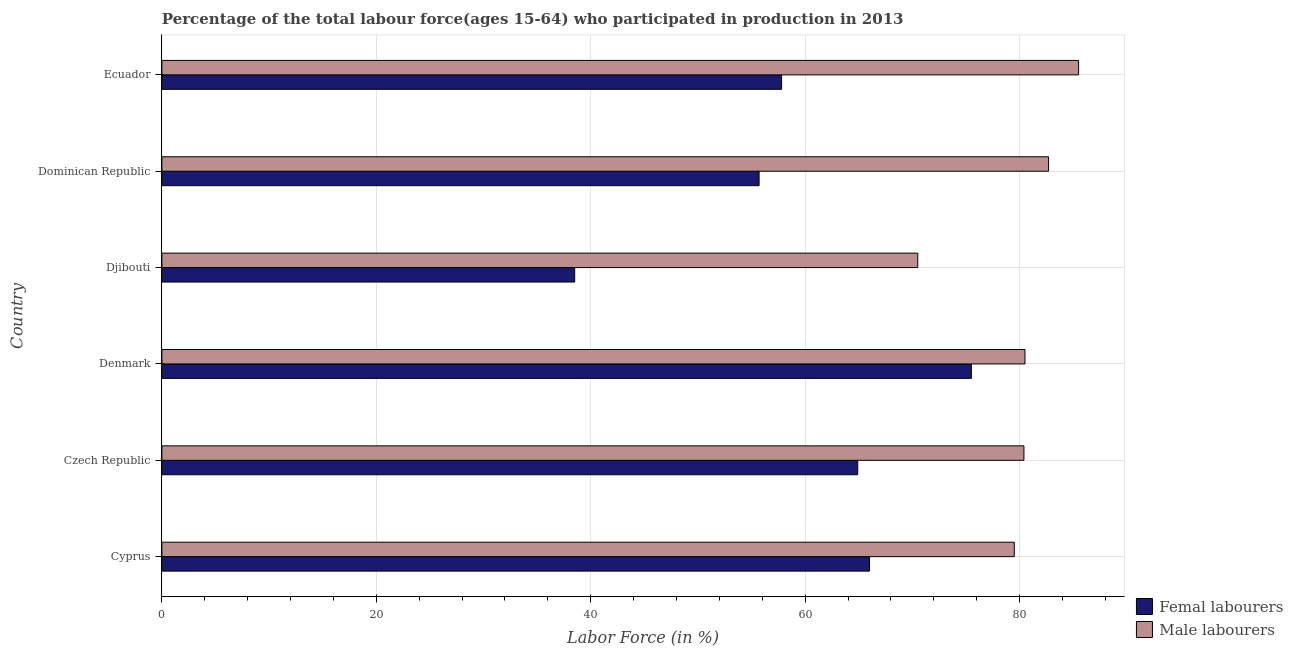Are the number of bars per tick equal to the number of legend labels?
Offer a terse response. Yes. How many bars are there on the 1st tick from the top?
Ensure brevity in your answer.  2. What is the label of the 5th group of bars from the top?
Provide a short and direct response. Czech Republic. What is the percentage of female labor force in Czech Republic?
Make the answer very short. 64.9. Across all countries, what is the maximum percentage of female labor force?
Make the answer very short. 75.5. Across all countries, what is the minimum percentage of female labor force?
Ensure brevity in your answer.  38.5. In which country was the percentage of female labor force maximum?
Keep it short and to the point. Denmark. In which country was the percentage of male labour force minimum?
Your response must be concise. Djibouti. What is the total percentage of female labor force in the graph?
Give a very brief answer. 358.4. What is the difference between the percentage of female labor force in Czech Republic and that in Denmark?
Ensure brevity in your answer.  -10.6. What is the difference between the percentage of female labor force in Czech Republic and the percentage of male labour force in Dominican Republic?
Provide a succinct answer. -17.8. What is the average percentage of male labour force per country?
Offer a terse response. 79.85. What is the ratio of the percentage of female labor force in Cyprus to that in Denmark?
Keep it short and to the point. 0.87. Is the percentage of female labor force in Czech Republic less than that in Ecuador?
Offer a very short reply. No. In how many countries, is the percentage of male labour force greater than the average percentage of male labour force taken over all countries?
Your response must be concise. 4. What does the 2nd bar from the top in Cyprus represents?
Make the answer very short. Femal labourers. What does the 1st bar from the bottom in Djibouti represents?
Your answer should be compact. Femal labourers. Are all the bars in the graph horizontal?
Ensure brevity in your answer.  Yes. Are the values on the major ticks of X-axis written in scientific E-notation?
Offer a very short reply. No. Does the graph contain any zero values?
Your answer should be very brief. No. Does the graph contain grids?
Make the answer very short. Yes. What is the title of the graph?
Offer a very short reply. Percentage of the total labour force(ages 15-64) who participated in production in 2013. What is the Labor Force (in %) in Male labourers in Cyprus?
Ensure brevity in your answer.  79.5. What is the Labor Force (in %) in Femal labourers in Czech Republic?
Ensure brevity in your answer.  64.9. What is the Labor Force (in %) of Male labourers in Czech Republic?
Give a very brief answer. 80.4. What is the Labor Force (in %) of Femal labourers in Denmark?
Keep it short and to the point. 75.5. What is the Labor Force (in %) of Male labourers in Denmark?
Your answer should be very brief. 80.5. What is the Labor Force (in %) in Femal labourers in Djibouti?
Give a very brief answer. 38.5. What is the Labor Force (in %) of Male labourers in Djibouti?
Make the answer very short. 70.5. What is the Labor Force (in %) of Femal labourers in Dominican Republic?
Provide a succinct answer. 55.7. What is the Labor Force (in %) of Male labourers in Dominican Republic?
Ensure brevity in your answer.  82.7. What is the Labor Force (in %) in Femal labourers in Ecuador?
Make the answer very short. 57.8. What is the Labor Force (in %) in Male labourers in Ecuador?
Your answer should be very brief. 85.5. Across all countries, what is the maximum Labor Force (in %) of Femal labourers?
Provide a succinct answer. 75.5. Across all countries, what is the maximum Labor Force (in %) in Male labourers?
Your answer should be compact. 85.5. Across all countries, what is the minimum Labor Force (in %) of Femal labourers?
Your answer should be very brief. 38.5. Across all countries, what is the minimum Labor Force (in %) in Male labourers?
Offer a very short reply. 70.5. What is the total Labor Force (in %) of Femal labourers in the graph?
Your answer should be very brief. 358.4. What is the total Labor Force (in %) of Male labourers in the graph?
Provide a short and direct response. 479.1. What is the difference between the Labor Force (in %) in Male labourers in Cyprus and that in Czech Republic?
Offer a terse response. -0.9. What is the difference between the Labor Force (in %) of Femal labourers in Cyprus and that in Djibouti?
Keep it short and to the point. 27.5. What is the difference between the Labor Force (in %) of Male labourers in Cyprus and that in Djibouti?
Your answer should be very brief. 9. What is the difference between the Labor Force (in %) in Femal labourers in Czech Republic and that in Denmark?
Your answer should be compact. -10.6. What is the difference between the Labor Force (in %) of Femal labourers in Czech Republic and that in Djibouti?
Your response must be concise. 26.4. What is the difference between the Labor Force (in %) in Femal labourers in Czech Republic and that in Dominican Republic?
Ensure brevity in your answer.  9.2. What is the difference between the Labor Force (in %) in Femal labourers in Czech Republic and that in Ecuador?
Keep it short and to the point. 7.1. What is the difference between the Labor Force (in %) in Male labourers in Czech Republic and that in Ecuador?
Make the answer very short. -5.1. What is the difference between the Labor Force (in %) in Male labourers in Denmark and that in Djibouti?
Provide a short and direct response. 10. What is the difference between the Labor Force (in %) in Femal labourers in Denmark and that in Dominican Republic?
Provide a succinct answer. 19.8. What is the difference between the Labor Force (in %) in Male labourers in Denmark and that in Ecuador?
Provide a short and direct response. -5. What is the difference between the Labor Force (in %) in Femal labourers in Djibouti and that in Dominican Republic?
Offer a very short reply. -17.2. What is the difference between the Labor Force (in %) of Femal labourers in Djibouti and that in Ecuador?
Provide a succinct answer. -19.3. What is the difference between the Labor Force (in %) in Femal labourers in Dominican Republic and that in Ecuador?
Your answer should be compact. -2.1. What is the difference between the Labor Force (in %) of Femal labourers in Cyprus and the Labor Force (in %) of Male labourers in Czech Republic?
Provide a succinct answer. -14.4. What is the difference between the Labor Force (in %) of Femal labourers in Cyprus and the Labor Force (in %) of Male labourers in Djibouti?
Offer a very short reply. -4.5. What is the difference between the Labor Force (in %) of Femal labourers in Cyprus and the Labor Force (in %) of Male labourers in Dominican Republic?
Ensure brevity in your answer.  -16.7. What is the difference between the Labor Force (in %) in Femal labourers in Cyprus and the Labor Force (in %) in Male labourers in Ecuador?
Give a very brief answer. -19.5. What is the difference between the Labor Force (in %) in Femal labourers in Czech Republic and the Labor Force (in %) in Male labourers in Denmark?
Your response must be concise. -15.6. What is the difference between the Labor Force (in %) of Femal labourers in Czech Republic and the Labor Force (in %) of Male labourers in Dominican Republic?
Provide a succinct answer. -17.8. What is the difference between the Labor Force (in %) in Femal labourers in Czech Republic and the Labor Force (in %) in Male labourers in Ecuador?
Make the answer very short. -20.6. What is the difference between the Labor Force (in %) in Femal labourers in Denmark and the Labor Force (in %) in Male labourers in Djibouti?
Provide a short and direct response. 5. What is the difference between the Labor Force (in %) of Femal labourers in Denmark and the Labor Force (in %) of Male labourers in Dominican Republic?
Offer a terse response. -7.2. What is the difference between the Labor Force (in %) of Femal labourers in Denmark and the Labor Force (in %) of Male labourers in Ecuador?
Ensure brevity in your answer.  -10. What is the difference between the Labor Force (in %) in Femal labourers in Djibouti and the Labor Force (in %) in Male labourers in Dominican Republic?
Offer a terse response. -44.2. What is the difference between the Labor Force (in %) in Femal labourers in Djibouti and the Labor Force (in %) in Male labourers in Ecuador?
Your answer should be compact. -47. What is the difference between the Labor Force (in %) in Femal labourers in Dominican Republic and the Labor Force (in %) in Male labourers in Ecuador?
Your answer should be very brief. -29.8. What is the average Labor Force (in %) of Femal labourers per country?
Give a very brief answer. 59.73. What is the average Labor Force (in %) in Male labourers per country?
Provide a succinct answer. 79.85. What is the difference between the Labor Force (in %) of Femal labourers and Labor Force (in %) of Male labourers in Cyprus?
Make the answer very short. -13.5. What is the difference between the Labor Force (in %) of Femal labourers and Labor Force (in %) of Male labourers in Czech Republic?
Keep it short and to the point. -15.5. What is the difference between the Labor Force (in %) of Femal labourers and Labor Force (in %) of Male labourers in Denmark?
Provide a succinct answer. -5. What is the difference between the Labor Force (in %) of Femal labourers and Labor Force (in %) of Male labourers in Djibouti?
Make the answer very short. -32. What is the difference between the Labor Force (in %) in Femal labourers and Labor Force (in %) in Male labourers in Dominican Republic?
Provide a succinct answer. -27. What is the difference between the Labor Force (in %) of Femal labourers and Labor Force (in %) of Male labourers in Ecuador?
Offer a terse response. -27.7. What is the ratio of the Labor Force (in %) of Femal labourers in Cyprus to that in Czech Republic?
Keep it short and to the point. 1.02. What is the ratio of the Labor Force (in %) of Femal labourers in Cyprus to that in Denmark?
Provide a short and direct response. 0.87. What is the ratio of the Labor Force (in %) of Male labourers in Cyprus to that in Denmark?
Provide a short and direct response. 0.99. What is the ratio of the Labor Force (in %) in Femal labourers in Cyprus to that in Djibouti?
Give a very brief answer. 1.71. What is the ratio of the Labor Force (in %) of Male labourers in Cyprus to that in Djibouti?
Offer a terse response. 1.13. What is the ratio of the Labor Force (in %) in Femal labourers in Cyprus to that in Dominican Republic?
Offer a very short reply. 1.18. What is the ratio of the Labor Force (in %) in Male labourers in Cyprus to that in Dominican Republic?
Keep it short and to the point. 0.96. What is the ratio of the Labor Force (in %) in Femal labourers in Cyprus to that in Ecuador?
Your answer should be very brief. 1.14. What is the ratio of the Labor Force (in %) in Male labourers in Cyprus to that in Ecuador?
Ensure brevity in your answer.  0.93. What is the ratio of the Labor Force (in %) in Femal labourers in Czech Republic to that in Denmark?
Your answer should be very brief. 0.86. What is the ratio of the Labor Force (in %) of Femal labourers in Czech Republic to that in Djibouti?
Provide a succinct answer. 1.69. What is the ratio of the Labor Force (in %) of Male labourers in Czech Republic to that in Djibouti?
Provide a succinct answer. 1.14. What is the ratio of the Labor Force (in %) in Femal labourers in Czech Republic to that in Dominican Republic?
Your answer should be very brief. 1.17. What is the ratio of the Labor Force (in %) in Male labourers in Czech Republic to that in Dominican Republic?
Provide a succinct answer. 0.97. What is the ratio of the Labor Force (in %) in Femal labourers in Czech Republic to that in Ecuador?
Your response must be concise. 1.12. What is the ratio of the Labor Force (in %) in Male labourers in Czech Republic to that in Ecuador?
Make the answer very short. 0.94. What is the ratio of the Labor Force (in %) in Femal labourers in Denmark to that in Djibouti?
Make the answer very short. 1.96. What is the ratio of the Labor Force (in %) in Male labourers in Denmark to that in Djibouti?
Offer a very short reply. 1.14. What is the ratio of the Labor Force (in %) in Femal labourers in Denmark to that in Dominican Republic?
Your answer should be compact. 1.36. What is the ratio of the Labor Force (in %) of Male labourers in Denmark to that in Dominican Republic?
Keep it short and to the point. 0.97. What is the ratio of the Labor Force (in %) of Femal labourers in Denmark to that in Ecuador?
Offer a very short reply. 1.31. What is the ratio of the Labor Force (in %) in Male labourers in Denmark to that in Ecuador?
Make the answer very short. 0.94. What is the ratio of the Labor Force (in %) of Femal labourers in Djibouti to that in Dominican Republic?
Provide a short and direct response. 0.69. What is the ratio of the Labor Force (in %) of Male labourers in Djibouti to that in Dominican Republic?
Provide a short and direct response. 0.85. What is the ratio of the Labor Force (in %) in Femal labourers in Djibouti to that in Ecuador?
Your response must be concise. 0.67. What is the ratio of the Labor Force (in %) in Male labourers in Djibouti to that in Ecuador?
Your response must be concise. 0.82. What is the ratio of the Labor Force (in %) of Femal labourers in Dominican Republic to that in Ecuador?
Give a very brief answer. 0.96. What is the ratio of the Labor Force (in %) of Male labourers in Dominican Republic to that in Ecuador?
Give a very brief answer. 0.97. What is the difference between the highest and the second highest Labor Force (in %) in Male labourers?
Your answer should be very brief. 2.8. 